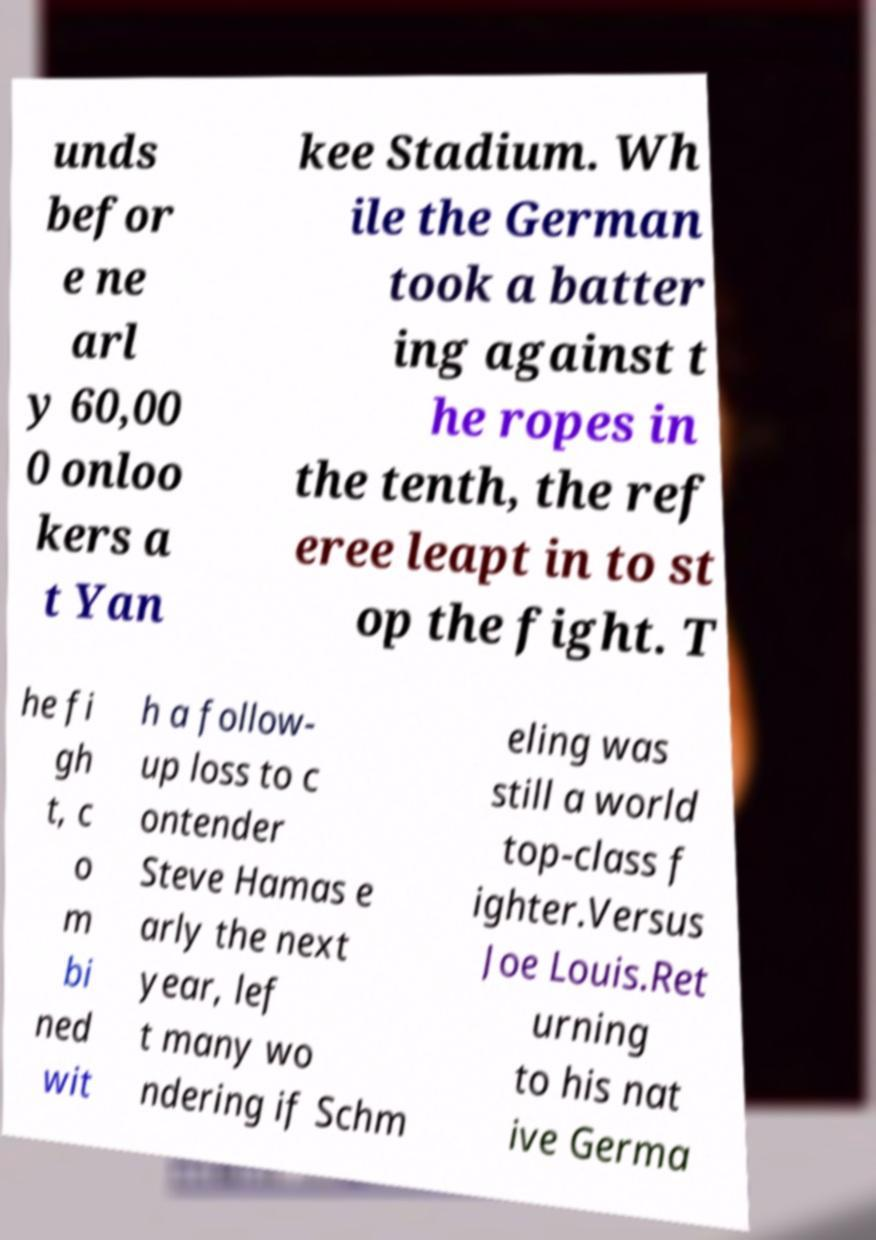Can you read and provide the text displayed in the image?This photo seems to have some interesting text. Can you extract and type it out for me? unds befor e ne arl y 60,00 0 onloo kers a t Yan kee Stadium. Wh ile the German took a batter ing against t he ropes in the tenth, the ref eree leapt in to st op the fight. T he fi gh t, c o m bi ned wit h a follow- up loss to c ontender Steve Hamas e arly the next year, lef t many wo ndering if Schm eling was still a world top-class f ighter.Versus Joe Louis.Ret urning to his nat ive Germa 